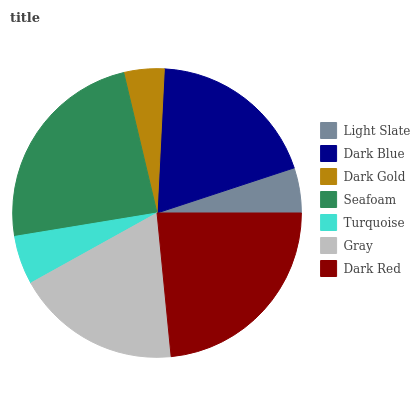Is Dark Gold the minimum?
Answer yes or no. Yes. Is Seafoam the maximum?
Answer yes or no. Yes. Is Dark Blue the minimum?
Answer yes or no. No. Is Dark Blue the maximum?
Answer yes or no. No. Is Dark Blue greater than Light Slate?
Answer yes or no. Yes. Is Light Slate less than Dark Blue?
Answer yes or no. Yes. Is Light Slate greater than Dark Blue?
Answer yes or no. No. Is Dark Blue less than Light Slate?
Answer yes or no. No. Is Gray the high median?
Answer yes or no. Yes. Is Gray the low median?
Answer yes or no. Yes. Is Turquoise the high median?
Answer yes or no. No. Is Dark Gold the low median?
Answer yes or no. No. 